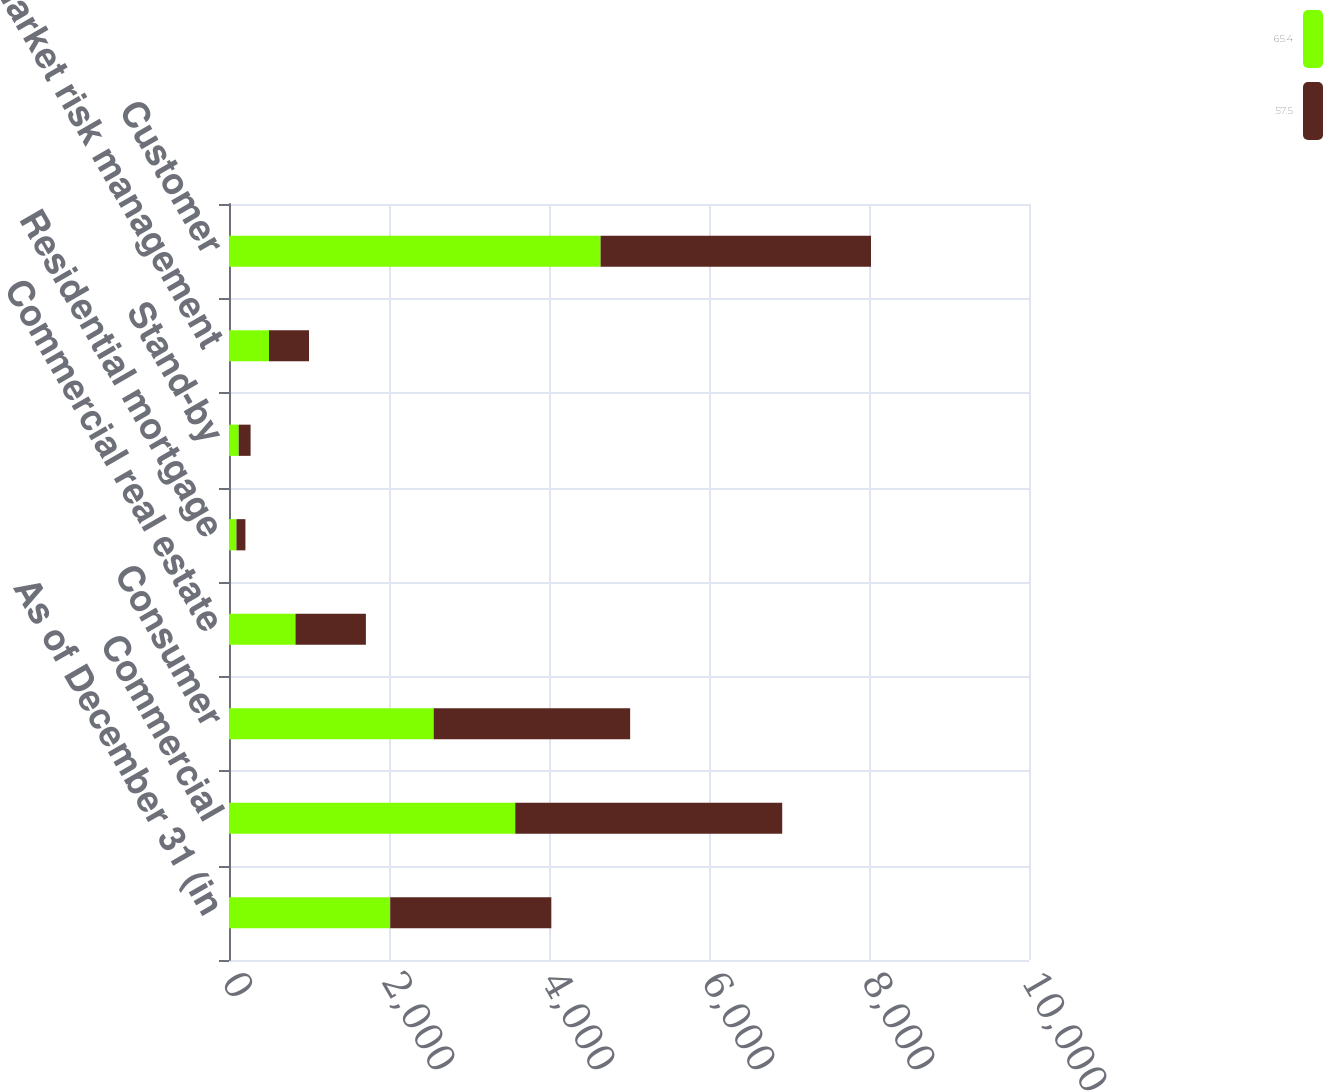<chart> <loc_0><loc_0><loc_500><loc_500><stacked_bar_chart><ecel><fcel>As of December 31 (in<fcel>Commercial<fcel>Consumer<fcel>Commercial real estate<fcel>Residential mortgage<fcel>Stand-by<fcel>For market risk management<fcel>Customer<nl><fcel>65.4<fcel>2015<fcel>3578<fcel>2558.4<fcel>831<fcel>93.3<fcel>121.5<fcel>500<fcel>4644.8<nl><fcel>57.5<fcel>2014<fcel>3337.2<fcel>2455.9<fcel>880.1<fcel>111.8<fcel>148.3<fcel>500<fcel>3380.2<nl></chart> 